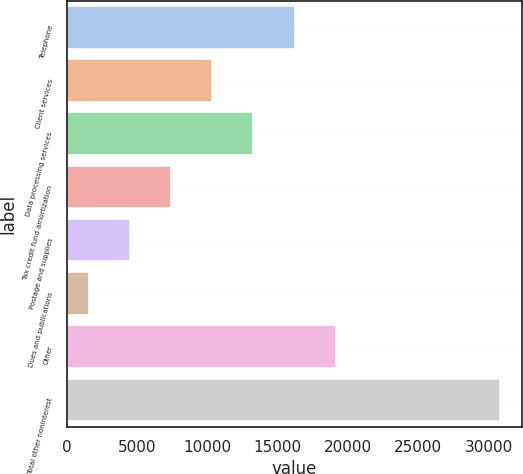Convert chart to OTSL. <chart><loc_0><loc_0><loc_500><loc_500><bar_chart><fcel>Telephone<fcel>Client services<fcel>Data processing services<fcel>Tax credit fund amortization<fcel>Postage and supplies<fcel>Dues and publications<fcel>Other<fcel>Total other noninterest<nl><fcel>16196<fcel>10345.6<fcel>13270.8<fcel>7420.4<fcel>4495.2<fcel>1570<fcel>19121.2<fcel>30822<nl></chart> 